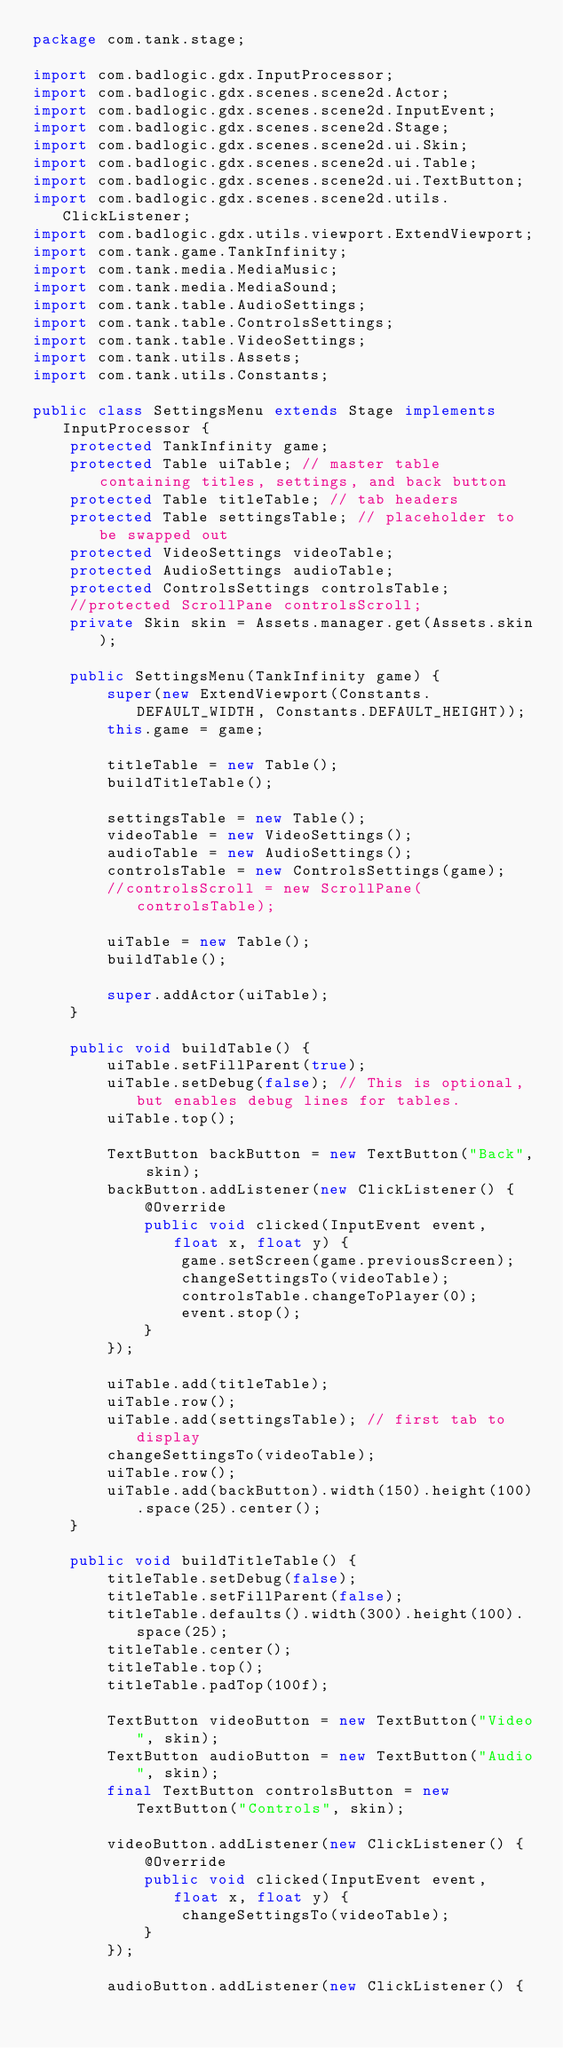Convert code to text. <code><loc_0><loc_0><loc_500><loc_500><_Java_>package com.tank.stage;

import com.badlogic.gdx.InputProcessor;
import com.badlogic.gdx.scenes.scene2d.Actor;
import com.badlogic.gdx.scenes.scene2d.InputEvent;
import com.badlogic.gdx.scenes.scene2d.Stage;
import com.badlogic.gdx.scenes.scene2d.ui.Skin;
import com.badlogic.gdx.scenes.scene2d.ui.Table;
import com.badlogic.gdx.scenes.scene2d.ui.TextButton;
import com.badlogic.gdx.scenes.scene2d.utils.ClickListener;
import com.badlogic.gdx.utils.viewport.ExtendViewport;
import com.tank.game.TankInfinity;
import com.tank.media.MediaMusic;
import com.tank.media.MediaSound;
import com.tank.table.AudioSettings;
import com.tank.table.ControlsSettings;
import com.tank.table.VideoSettings;
import com.tank.utils.Assets;
import com.tank.utils.Constants;

public class SettingsMenu extends Stage implements InputProcessor {
	protected TankInfinity game;
	protected Table uiTable; // master table containing titles, settings, and back button
	protected Table titleTable; // tab headers
	protected Table settingsTable; // placeholder to be swapped out
	protected VideoSettings videoTable;
	protected AudioSettings audioTable;
	protected ControlsSettings controlsTable;
	//protected ScrollPane controlsScroll;
	private Skin skin = Assets.manager.get(Assets.skin);

	public SettingsMenu(TankInfinity game) {
		super(new ExtendViewport(Constants.DEFAULT_WIDTH, Constants.DEFAULT_HEIGHT));
		this.game = game;

		titleTable = new Table();
		buildTitleTable();

		settingsTable = new Table();
		videoTable = new VideoSettings();
		audioTable = new AudioSettings();
		controlsTable = new ControlsSettings(game);
		//controlsScroll = new ScrollPane(controlsTable);

		uiTable = new Table();
		buildTable();

		super.addActor(uiTable);
	}

	public void buildTable() {
		uiTable.setFillParent(true);
		uiTable.setDebug(false); // This is optional, but enables debug lines for tables.
		uiTable.top();

		TextButton backButton = new TextButton("Back", skin);
		backButton.addListener(new ClickListener() {
			@Override
			public void clicked(InputEvent event, float x, float y) {
				game.setScreen(game.previousScreen);
				changeSettingsTo(videoTable);
				controlsTable.changeToPlayer(0);
				event.stop();
			}
		});

		uiTable.add(titleTable);
		uiTable.row();
		uiTable.add(settingsTable); // first tab to display
		changeSettingsTo(videoTable);
		uiTable.row();
		uiTable.add(backButton).width(150).height(100).space(25).center();
	}

	public void buildTitleTable() {
		titleTable.setDebug(false);
		titleTable.setFillParent(false);
		titleTable.defaults().width(300).height(100).space(25);
		titleTable.center();
		titleTable.top();
		titleTable.padTop(100f);

		TextButton videoButton = new TextButton("Video", skin);
		TextButton audioButton = new TextButton("Audio", skin);
		final TextButton controlsButton = new TextButton("Controls", skin);

		videoButton.addListener(new ClickListener() {
			@Override
			public void clicked(InputEvent event, float x, float y) {
				changeSettingsTo(videoTable);
			}
		});

		audioButton.addListener(new ClickListener() {</code> 